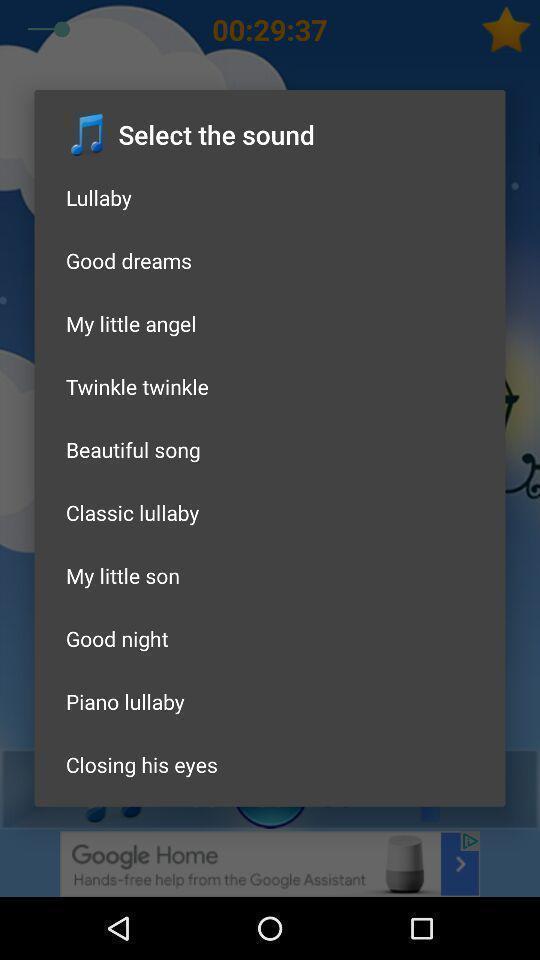Explain the elements present in this screenshot. Pop-up is displaying multiple sounds. 